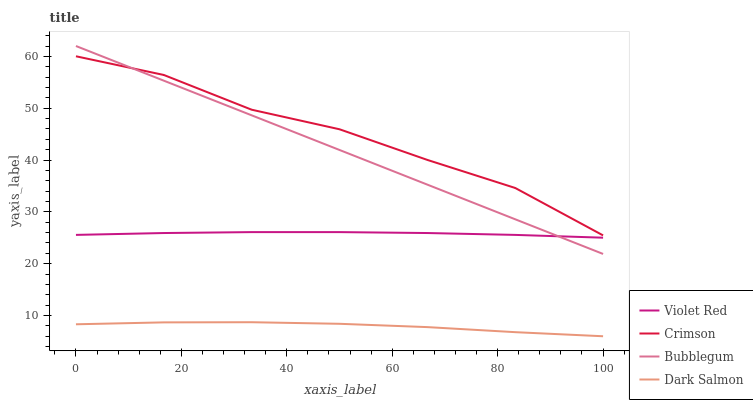Does Violet Red have the minimum area under the curve?
Answer yes or no. No. Does Violet Red have the maximum area under the curve?
Answer yes or no. No. Is Violet Red the smoothest?
Answer yes or no. No. Is Violet Red the roughest?
Answer yes or no. No. Does Violet Red have the lowest value?
Answer yes or no. No. Does Violet Red have the highest value?
Answer yes or no. No. Is Dark Salmon less than Bubblegum?
Answer yes or no. Yes. Is Bubblegum greater than Dark Salmon?
Answer yes or no. Yes. Does Dark Salmon intersect Bubblegum?
Answer yes or no. No. 